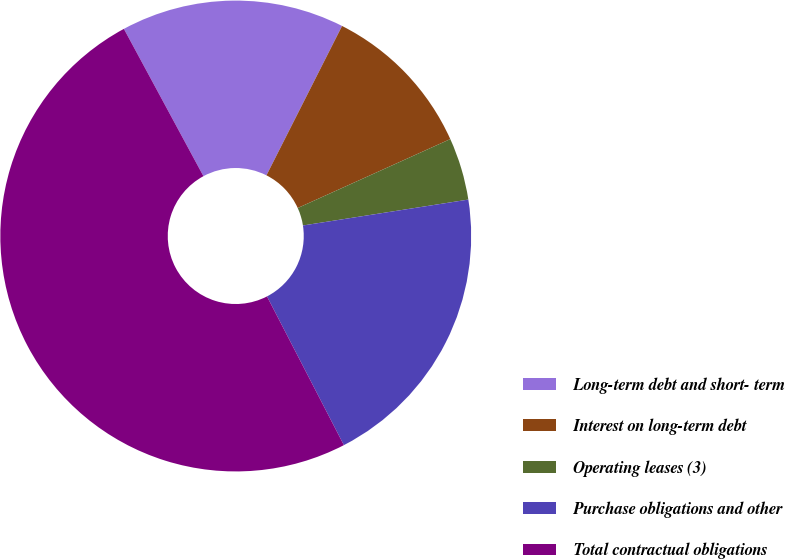Convert chart. <chart><loc_0><loc_0><loc_500><loc_500><pie_chart><fcel>Long-term debt and short- term<fcel>Interest on long-term debt<fcel>Operating leases (3)<fcel>Purchase obligations and other<fcel>Total contractual obligations<nl><fcel>15.34%<fcel>10.79%<fcel>4.28%<fcel>19.88%<fcel>49.72%<nl></chart> 